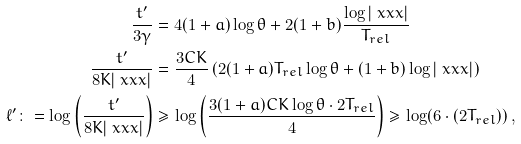<formula> <loc_0><loc_0><loc_500><loc_500>\frac { t ^ { \prime } } { 3 \gamma } & = 4 ( 1 + a ) \log \theta + 2 ( 1 + b ) \frac { \log | \ x x x | } { T _ { r e l } } \\ \frac { t ^ { \prime } } { 8 K | \ x x x | } & = \frac { 3 C K } { 4 } \left ( 2 ( 1 + a ) T _ { r e l } \log \theta + ( 1 + b ) \log | \ x x x | \right ) \\ \ell ^ { \prime } \colon = \log \left ( \frac { t ^ { \prime } } { 8 K | \ x x x | } \right ) & \geq \log \left ( \frac { 3 ( 1 + a ) C K \log \theta \cdot 2 T _ { r e l } } { 4 } \right ) \geq \log ( 6 \cdot ( 2 T _ { r e l } ) ) \, ,</formula> 